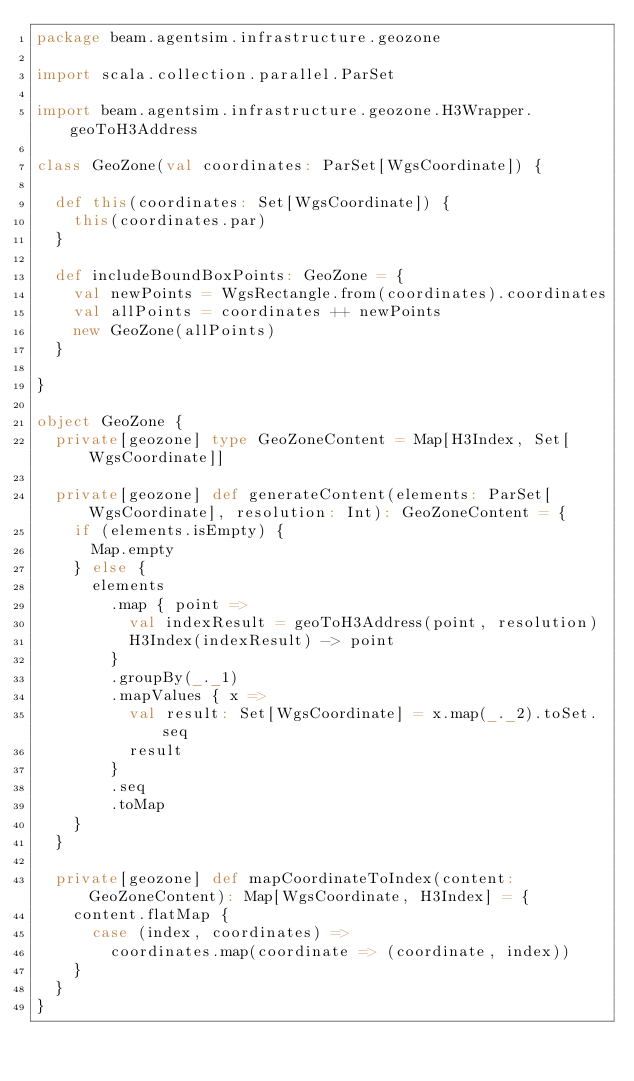Convert code to text. <code><loc_0><loc_0><loc_500><loc_500><_Scala_>package beam.agentsim.infrastructure.geozone

import scala.collection.parallel.ParSet

import beam.agentsim.infrastructure.geozone.H3Wrapper.geoToH3Address

class GeoZone(val coordinates: ParSet[WgsCoordinate]) {

  def this(coordinates: Set[WgsCoordinate]) {
    this(coordinates.par)
  }

  def includeBoundBoxPoints: GeoZone = {
    val newPoints = WgsRectangle.from(coordinates).coordinates
    val allPoints = coordinates ++ newPoints
    new GeoZone(allPoints)
  }

}

object GeoZone {
  private[geozone] type GeoZoneContent = Map[H3Index, Set[WgsCoordinate]]

  private[geozone] def generateContent(elements: ParSet[WgsCoordinate], resolution: Int): GeoZoneContent = {
    if (elements.isEmpty) {
      Map.empty
    } else {
      elements
        .map { point =>
          val indexResult = geoToH3Address(point, resolution)
          H3Index(indexResult) -> point
        }
        .groupBy(_._1)
        .mapValues { x =>
          val result: Set[WgsCoordinate] = x.map(_._2).toSet.seq
          result
        }
        .seq
        .toMap
    }
  }

  private[geozone] def mapCoordinateToIndex(content: GeoZoneContent): Map[WgsCoordinate, H3Index] = {
    content.flatMap {
      case (index, coordinates) =>
        coordinates.map(coordinate => (coordinate, index))
    }
  }
}
</code> 